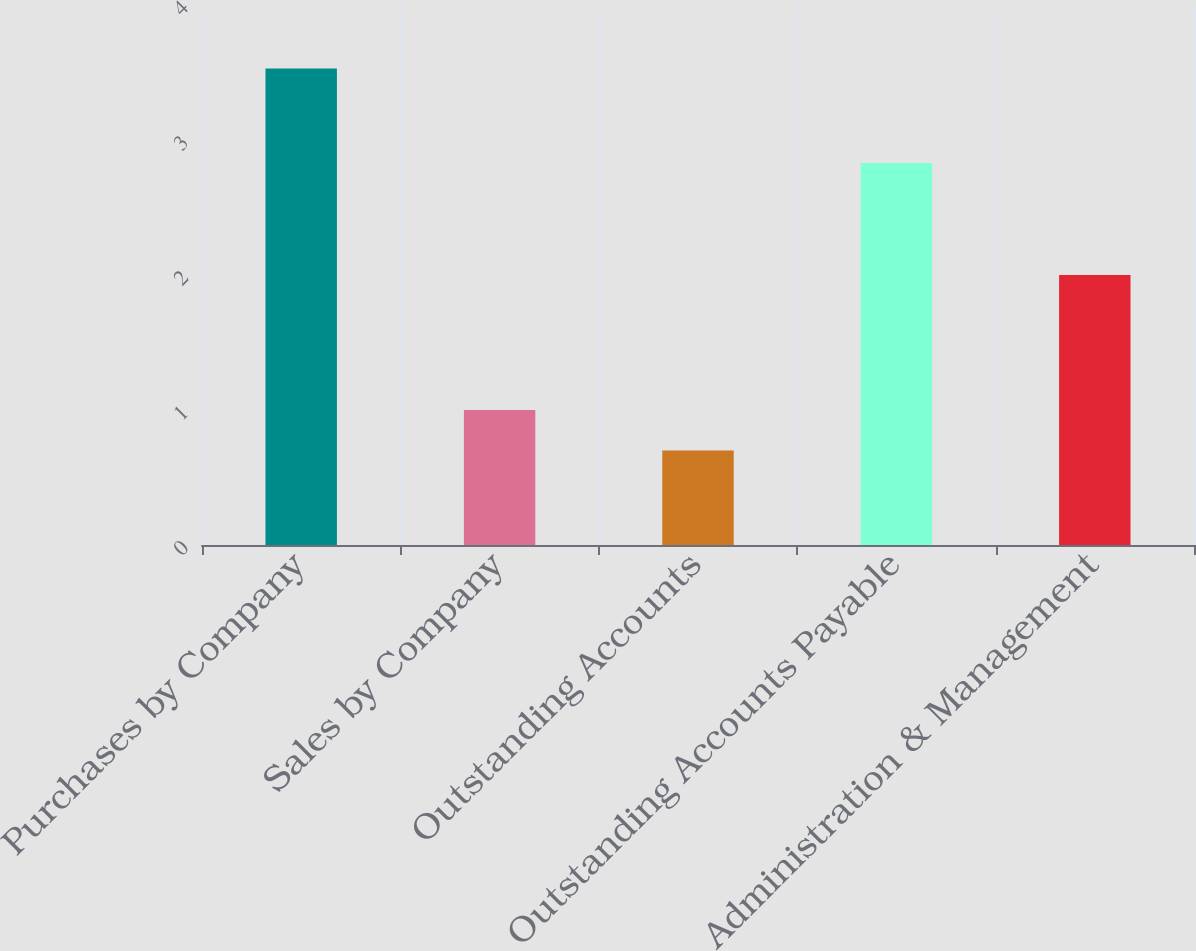<chart> <loc_0><loc_0><loc_500><loc_500><bar_chart><fcel>Purchases by Company<fcel>Sales by Company<fcel>Outstanding Accounts<fcel>Outstanding Accounts Payable<fcel>Administration & Management<nl><fcel>3.53<fcel>1<fcel>0.7<fcel>2.83<fcel>2<nl></chart> 